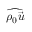Convert formula to latex. <formula><loc_0><loc_0><loc_500><loc_500>\widehat { \rho _ { 0 } \vec { u } }</formula> 